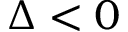Convert formula to latex. <formula><loc_0><loc_0><loc_500><loc_500>\Delta < 0</formula> 